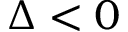Convert formula to latex. <formula><loc_0><loc_0><loc_500><loc_500>\Delta < 0</formula> 